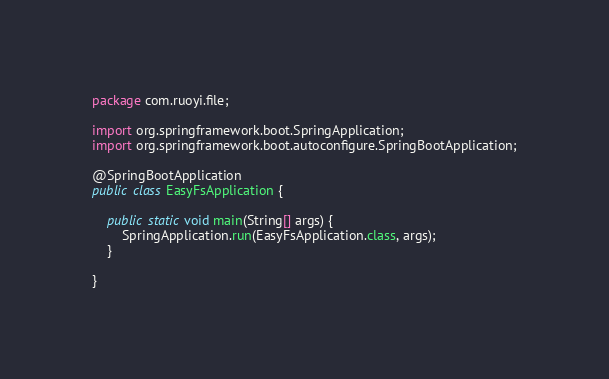Convert code to text. <code><loc_0><loc_0><loc_500><loc_500><_Java_>package com.ruoyi.file;

import org.springframework.boot.SpringApplication;
import org.springframework.boot.autoconfigure.SpringBootApplication;

@SpringBootApplication
public class EasyFsApplication {

    public static void main(String[] args) {
        SpringApplication.run(EasyFsApplication.class, args);
    }

}

</code> 